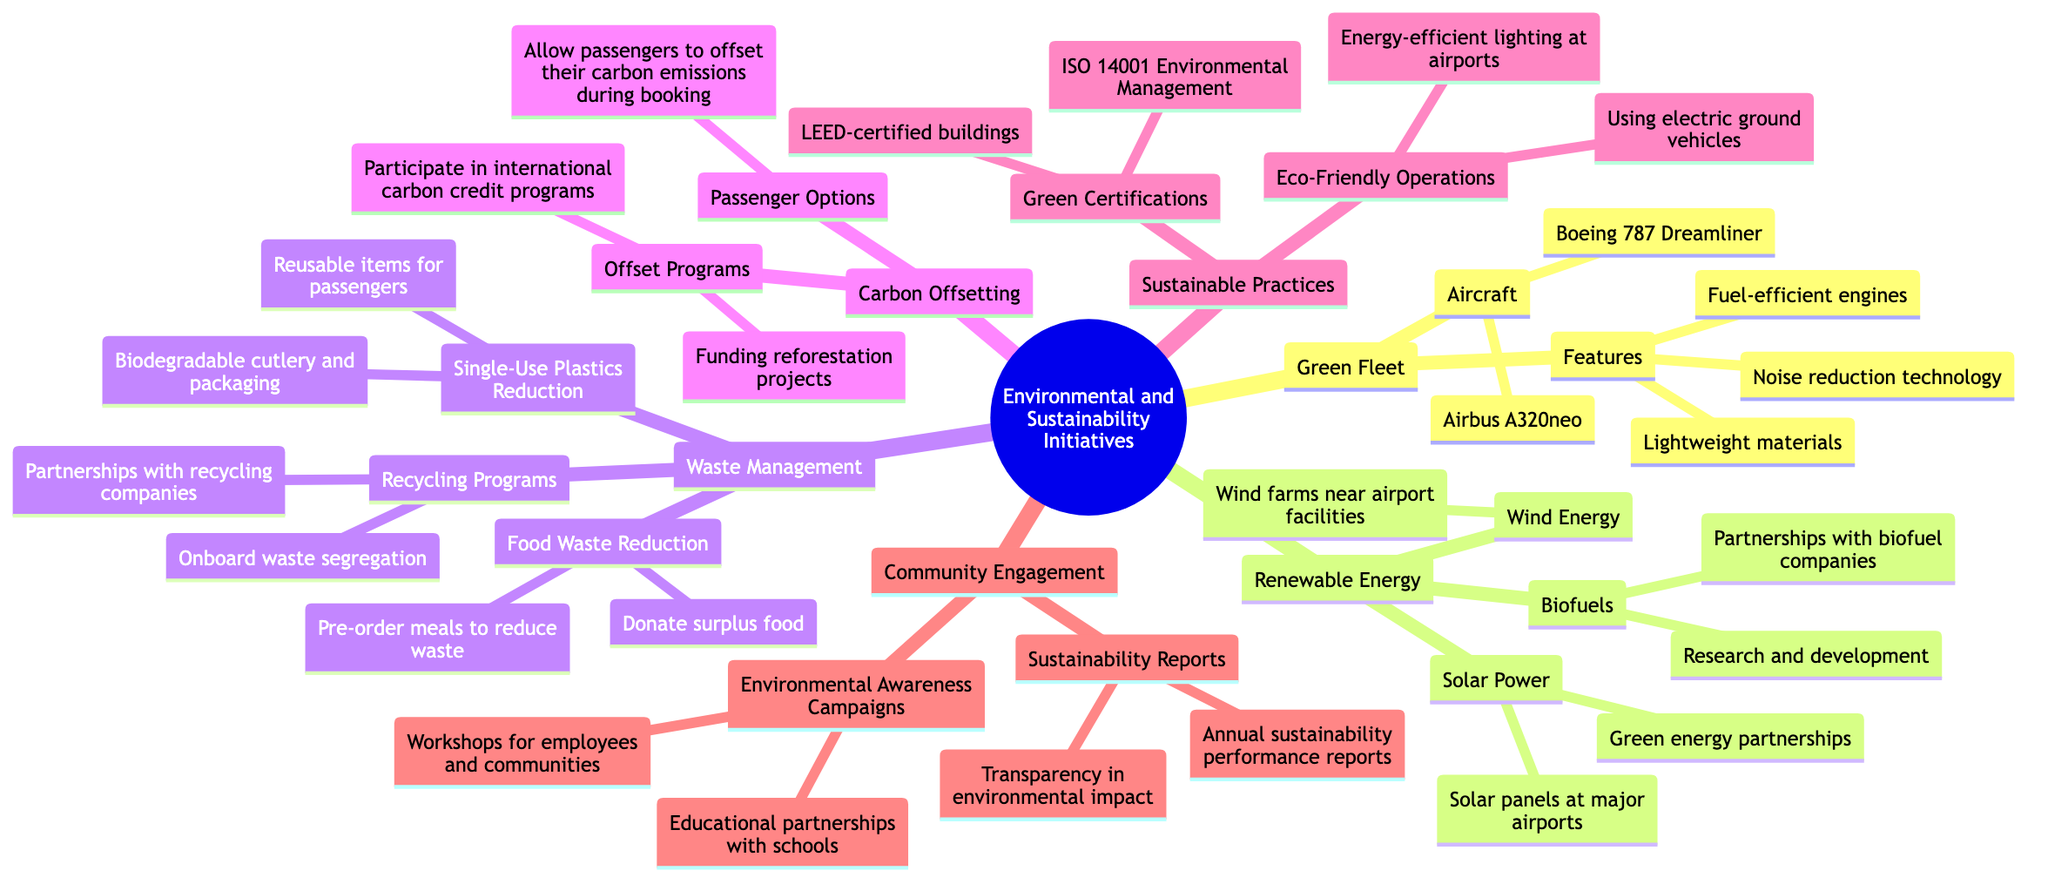What types of aircraft are included in the Green Fleet? The Green Fleet section of the diagram lists two specific aircraft types: Boeing 787 Dreamliner and Airbus A320neo. These are presented directly under the "Aircraft" node.
Answer: Boeing 787 Dreamliner, Airbus A320neo How many features are listed under the Green Fleet? Under the Green Fleet section, there are three features mentioned: fuel-efficient engines, lightweight materials, and noise reduction technology. These are found directly under the "Features" node.
Answer: 3 Which community engagement initiatives are highlighted? The Community Engagement section presents two initiatives: Environmental Awareness Campaigns and Sustainability Reports. These are the two primary categories listed under this section of the diagram.
Answer: Environmental Awareness Campaigns, Sustainability Reports What is one of the renewable energy strategies mentioned? In the Renewable Energy section, there are multiple strategies mentioned, including Solar Power, Wind Energy, and Biofuels. One specific example is Solar Power. This can be seen as highlighted within the Renewable Energy node.
Answer: Solar Power What percentage of the diagram is dedicated to Carbon Offsetting? The diagram does not provide a specific percentage for Carbon Offsetting, however, it shows that there is one dedicated node for it among six main nodes. This reasoning helps identify its relative proportion within the entire diagram structure.
Answer: Approximately 16.67% How does the Waste Management section aim to reduce single-use plastics? The Waste Management section specifically mentions a couple of strategies for single-use plastics reduction: biodegradable cutlery and packaging, and the use of reusable items for passengers. These are detailed directly under the "Single-Use Plastics Reduction" node.
Answer: Biodegradable cutlery and packaging, Reusable items for passengers Which certification is listed under Sustainable Practices? The Sustainable Practices section contains a node pertaining to Green Certifications, which includes LEED-certified buildings and ISO 14001 Environmental Management—these are recognized certifications listed within that node.
Answer: LEED-certified buildings, ISO 14001 Environmental Management How many elements are listed in the Carbon Offsetting section? The Carbon Offsetting section contains two main elements: Offset Programs and Passenger Options. Each of these elements outlines specific initiatives, thus there are a total of two key segments here.
Answer: 2 